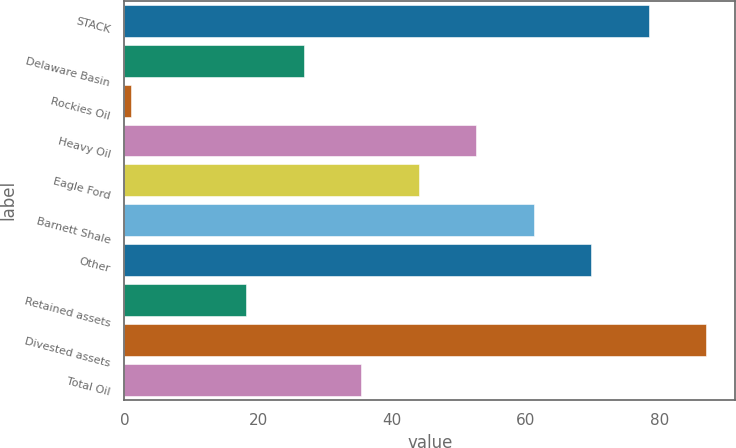Convert chart to OTSL. <chart><loc_0><loc_0><loc_500><loc_500><bar_chart><fcel>STACK<fcel>Delaware Basin<fcel>Rockies Oil<fcel>Heavy Oil<fcel>Eagle Ford<fcel>Barnett Shale<fcel>Other<fcel>Retained assets<fcel>Divested assets<fcel>Total Oil<nl><fcel>78.4<fcel>26.8<fcel>1<fcel>52.6<fcel>44<fcel>61.2<fcel>69.8<fcel>18.2<fcel>87<fcel>35.4<nl></chart> 